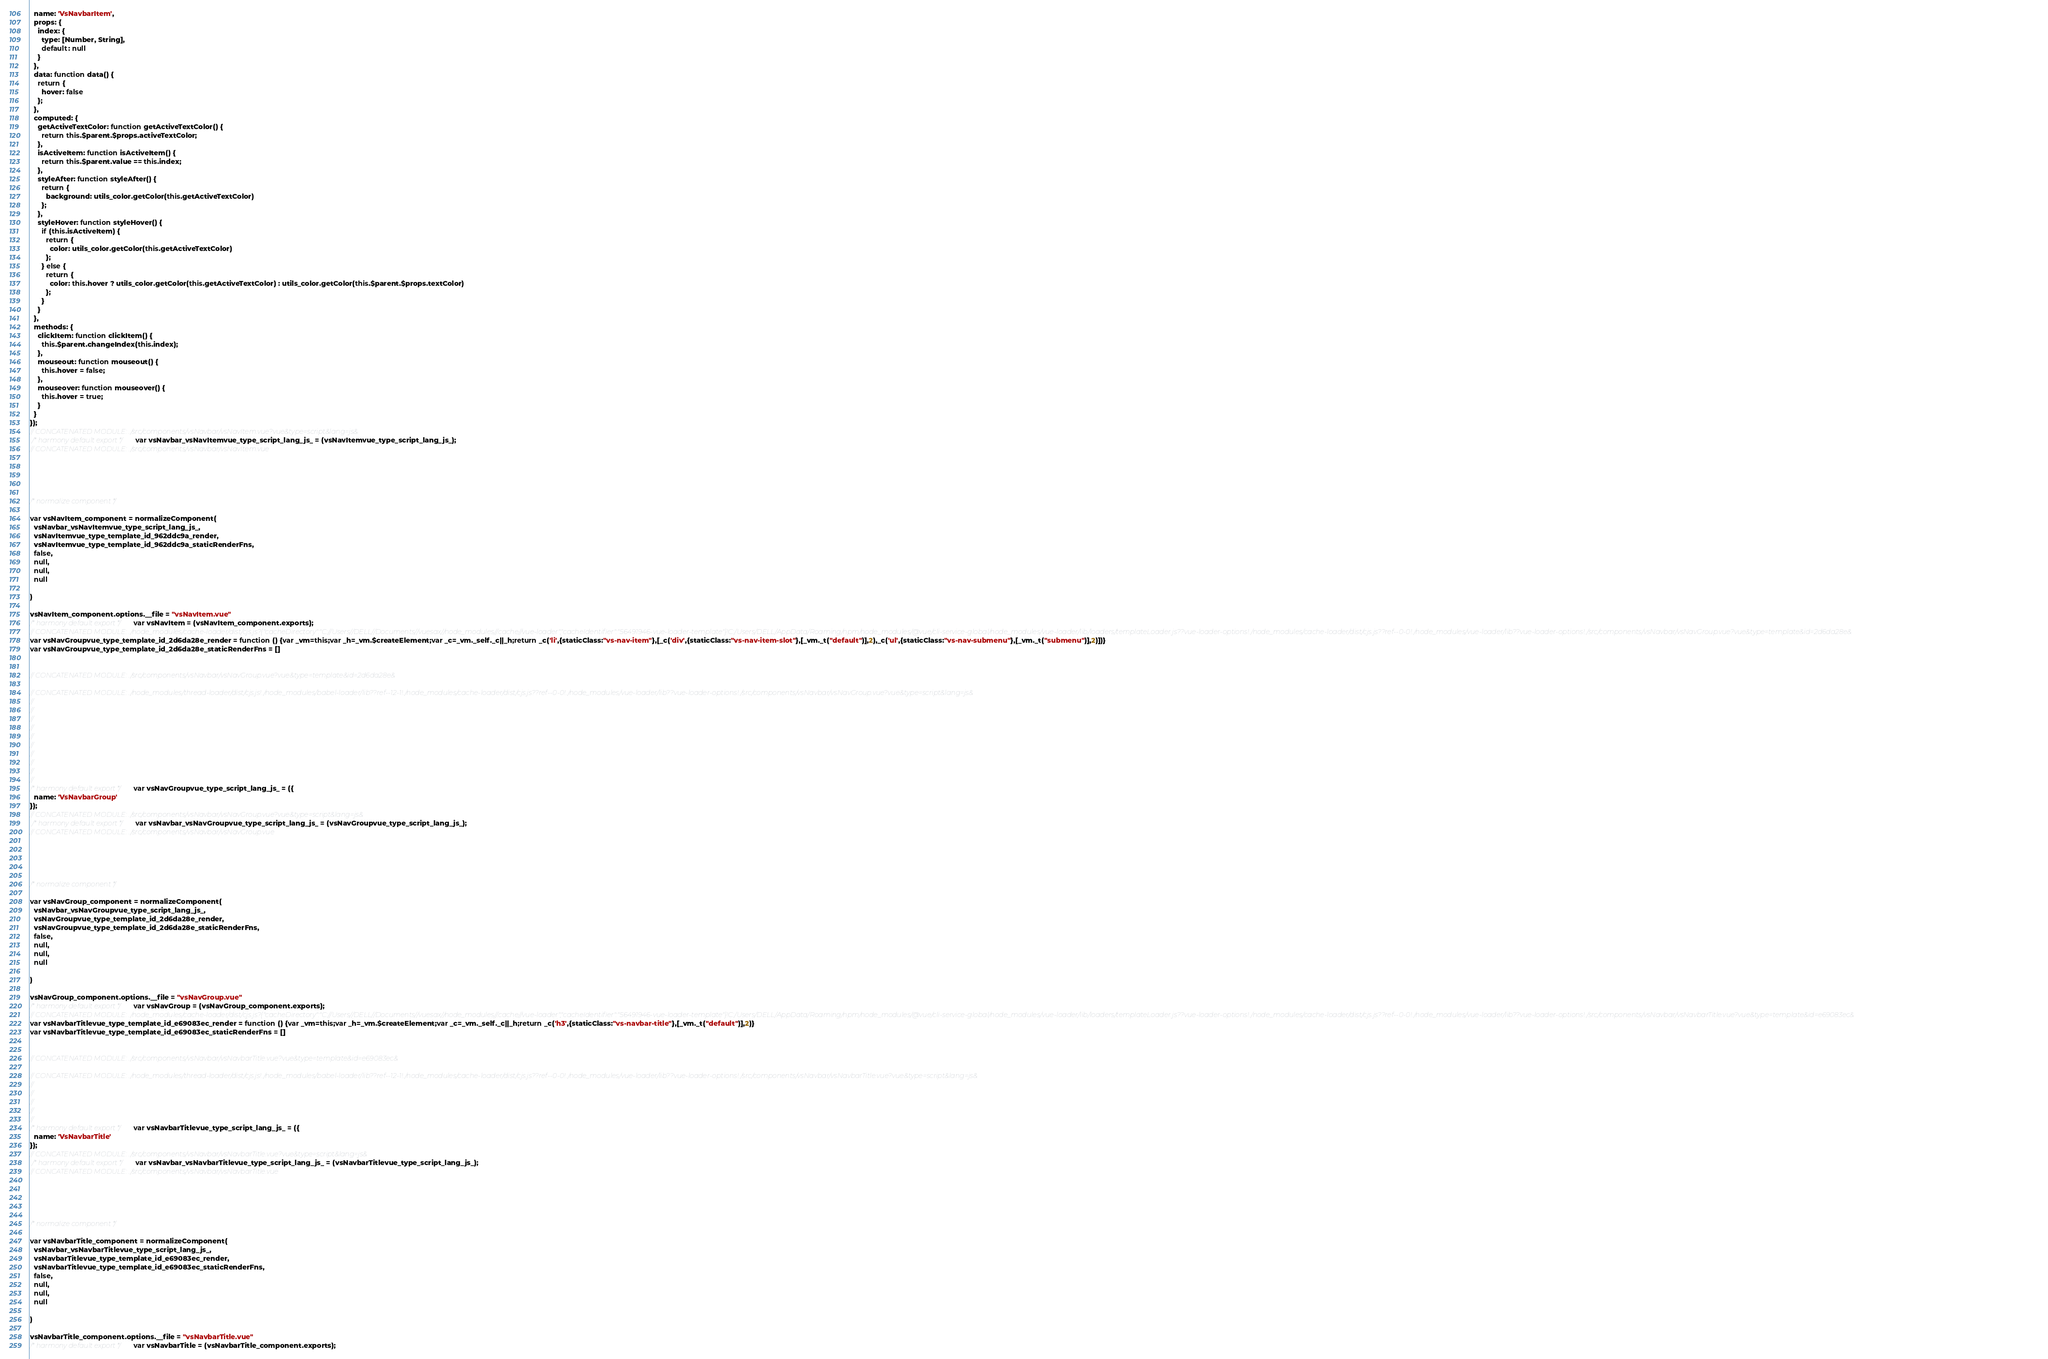<code> <loc_0><loc_0><loc_500><loc_500><_JavaScript_>  name: 'VsNavbarItem',
  props: {
    index: {
      type: [Number, String],
      default: null
    }
  },
  data: function data() {
    return {
      hover: false
    };
  },
  computed: {
    getActiveTextColor: function getActiveTextColor() {
      return this.$parent.$props.activeTextColor;
    },
    isActiveItem: function isActiveItem() {
      return this.$parent.value == this.index;
    },
    styleAfter: function styleAfter() {
      return {
        background: utils_color.getColor(this.getActiveTextColor)
      };
    },
    styleHover: function styleHover() {
      if (this.isActiveItem) {
        return {
          color: utils_color.getColor(this.getActiveTextColor)
        };
      } else {
        return {
          color: this.hover ? utils_color.getColor(this.getActiveTextColor) : utils_color.getColor(this.$parent.$props.textColor)
        };
      }
    }
  },
  methods: {
    clickItem: function clickItem() {
      this.$parent.changeIndex(this.index);
    },
    mouseout: function mouseout() {
      this.hover = false;
    },
    mouseover: function mouseover() {
      this.hover = true;
    }
  }
});
// CONCATENATED MODULE: ./src/components/vsNavbar/vsNavItem.vue?vue&type=script&lang=js&
 /* harmony default export */ var vsNavbar_vsNavItemvue_type_script_lang_js_ = (vsNavItemvue_type_script_lang_js_); 
// CONCATENATED MODULE: ./src/components/vsNavbar/vsNavItem.vue





/* normalize component */

var vsNavItem_component = normalizeComponent(
  vsNavbar_vsNavItemvue_type_script_lang_js_,
  vsNavItemvue_type_template_id_962ddc9a_render,
  vsNavItemvue_type_template_id_962ddc9a_staticRenderFns,
  false,
  null,
  null,
  null
  
)

vsNavItem_component.options.__file = "vsNavItem.vue"
/* harmony default export */ var vsNavItem = (vsNavItem_component.exports);
// CONCATENATED MODULE: ./node_modules/cache-loader/dist/cjs.js?{"cacheDirectory":"C://Users//DELL//Documents//vuesax//node_modules//.cache//vue-loader","cacheIdentifier":"56491946-vue-loader-template"}!C:/Users/DELL/AppData/Roaming/npm/node_modules/@vue/cli-service-global/node_modules/vue-loader/lib/loaders/templateLoader.js??vue-loader-options!./node_modules/cache-loader/dist/cjs.js??ref--0-0!./node_modules/vue-loader/lib??vue-loader-options!./src/components/vsNavbar/vsNavGroup.vue?vue&type=template&id=2d6da28e&
var vsNavGroupvue_type_template_id_2d6da28e_render = function () {var _vm=this;var _h=_vm.$createElement;var _c=_vm._self._c||_h;return _c('li',{staticClass:"vs-nav-item"},[_c('div',{staticClass:"vs-nav-item-slot"},[_vm._t("default")],2),_c('ul',{staticClass:"vs-nav-submenu"},[_vm._t("submenu")],2)])}
var vsNavGroupvue_type_template_id_2d6da28e_staticRenderFns = []


// CONCATENATED MODULE: ./src/components/vsNavbar/vsNavGroup.vue?vue&type=template&id=2d6da28e&

// CONCATENATED MODULE: ./node_modules/thread-loader/dist/cjs.js!./node_modules/babel-loader/lib??ref--12-1!./node_modules/cache-loader/dist/cjs.js??ref--0-0!./node_modules/vue-loader/lib??vue-loader-options!./src/components/vsNavbar/vsNavGroup.vue?vue&type=script&lang=js&
//
//
//
//
//
//
//
//
//
//
/* harmony default export */ var vsNavGroupvue_type_script_lang_js_ = ({
  name: 'VsNavbarGroup'
});
// CONCATENATED MODULE: ./src/components/vsNavbar/vsNavGroup.vue?vue&type=script&lang=js&
 /* harmony default export */ var vsNavbar_vsNavGroupvue_type_script_lang_js_ = (vsNavGroupvue_type_script_lang_js_); 
// CONCATENATED MODULE: ./src/components/vsNavbar/vsNavGroup.vue





/* normalize component */

var vsNavGroup_component = normalizeComponent(
  vsNavbar_vsNavGroupvue_type_script_lang_js_,
  vsNavGroupvue_type_template_id_2d6da28e_render,
  vsNavGroupvue_type_template_id_2d6da28e_staticRenderFns,
  false,
  null,
  null,
  null
  
)

vsNavGroup_component.options.__file = "vsNavGroup.vue"
/* harmony default export */ var vsNavGroup = (vsNavGroup_component.exports);
// CONCATENATED MODULE: ./node_modules/cache-loader/dist/cjs.js?{"cacheDirectory":"C://Users//DELL//Documents//vuesax//node_modules//.cache//vue-loader","cacheIdentifier":"56491946-vue-loader-template"}!C:/Users/DELL/AppData/Roaming/npm/node_modules/@vue/cli-service-global/node_modules/vue-loader/lib/loaders/templateLoader.js??vue-loader-options!./node_modules/cache-loader/dist/cjs.js??ref--0-0!./node_modules/vue-loader/lib??vue-loader-options!./src/components/vsNavbar/vsNavbarTitle.vue?vue&type=template&id=e69083ec&
var vsNavbarTitlevue_type_template_id_e69083ec_render = function () {var _vm=this;var _h=_vm.$createElement;var _c=_vm._self._c||_h;return _c('h3',{staticClass:"vs-navbar-title"},[_vm._t("default")],2)}
var vsNavbarTitlevue_type_template_id_e69083ec_staticRenderFns = []


// CONCATENATED MODULE: ./src/components/vsNavbar/vsNavbarTitle.vue?vue&type=template&id=e69083ec&

// CONCATENATED MODULE: ./node_modules/thread-loader/dist/cjs.js!./node_modules/babel-loader/lib??ref--12-1!./node_modules/cache-loader/dist/cjs.js??ref--0-0!./node_modules/vue-loader/lib??vue-loader-options!./src/components/vsNavbar/vsNavbarTitle.vue?vue&type=script&lang=js&
//
//
//
//
//
/* harmony default export */ var vsNavbarTitlevue_type_script_lang_js_ = ({
  name: 'VsNavbarTitle'
});
// CONCATENATED MODULE: ./src/components/vsNavbar/vsNavbarTitle.vue?vue&type=script&lang=js&
 /* harmony default export */ var vsNavbar_vsNavbarTitlevue_type_script_lang_js_ = (vsNavbarTitlevue_type_script_lang_js_); 
// CONCATENATED MODULE: ./src/components/vsNavbar/vsNavbarTitle.vue





/* normalize component */

var vsNavbarTitle_component = normalizeComponent(
  vsNavbar_vsNavbarTitlevue_type_script_lang_js_,
  vsNavbarTitlevue_type_template_id_e69083ec_render,
  vsNavbarTitlevue_type_template_id_e69083ec_staticRenderFns,
  false,
  null,
  null,
  null
  
)

vsNavbarTitle_component.options.__file = "vsNavbarTitle.vue"
/* harmony default export */ var vsNavbarTitle = (vsNavbarTitle_component.exports);</code> 